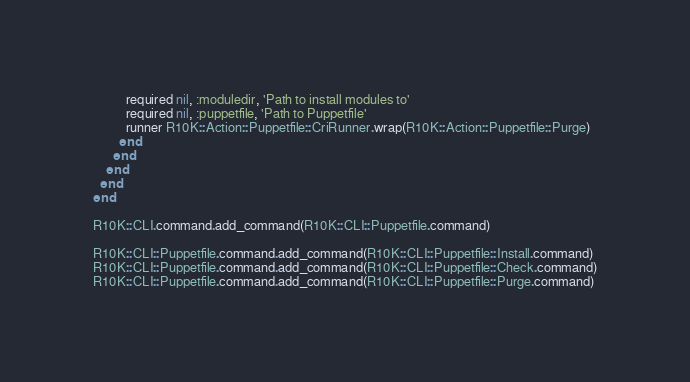<code> <loc_0><loc_0><loc_500><loc_500><_Ruby_>          required nil, :moduledir, 'Path to install modules to'
          required nil, :puppetfile, 'Path to Puppetfile'
          runner R10K::Action::Puppetfile::CriRunner.wrap(R10K::Action::Puppetfile::Purge)
        end
      end
    end
  end
end

R10K::CLI.command.add_command(R10K::CLI::Puppetfile.command)

R10K::CLI::Puppetfile.command.add_command(R10K::CLI::Puppetfile::Install.command)
R10K::CLI::Puppetfile.command.add_command(R10K::CLI::Puppetfile::Check.command)
R10K::CLI::Puppetfile.command.add_command(R10K::CLI::Puppetfile::Purge.command)
</code> 